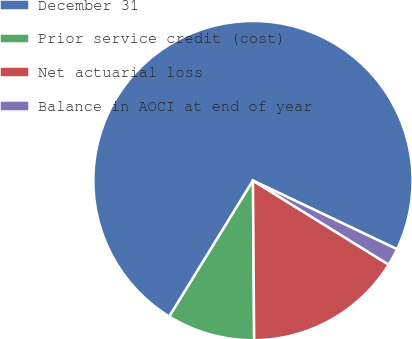Convert chart to OTSL. <chart><loc_0><loc_0><loc_500><loc_500><pie_chart><fcel>December 31<fcel>Prior service credit (cost)<fcel>Net actuarial loss<fcel>Balance in AOCI at end of year<nl><fcel>73.3%<fcel>8.9%<fcel>16.06%<fcel>1.75%<nl></chart> 